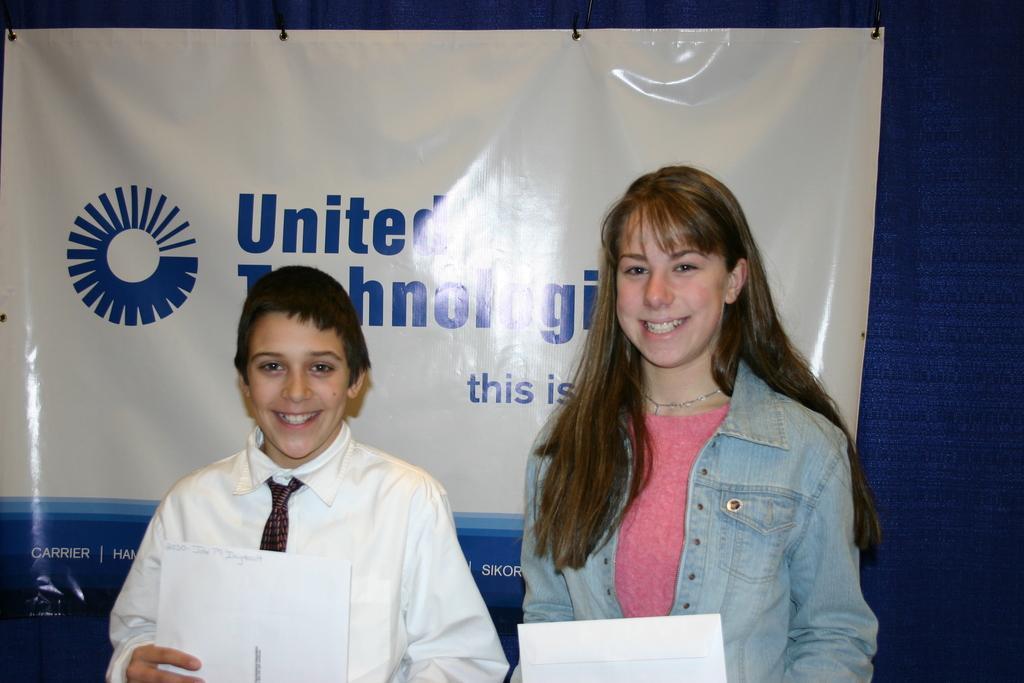How would you summarize this image in a sentence or two? In the image we can see a woman and a boy standing, wearing clothes and they are smiling, and they are holding paper in their hands. Behind them, we can see the banner and we can see the text on it. 